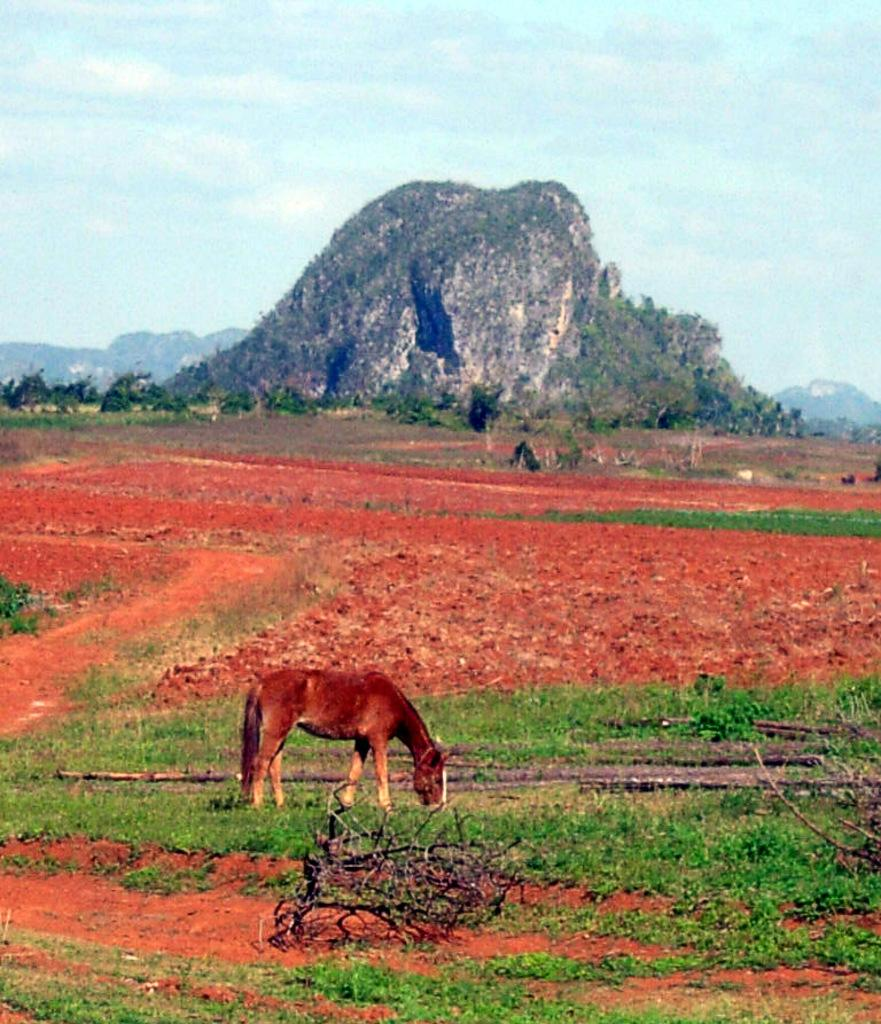What type of animal can be seen on the grass in the image? There is an animal on the surface of the grass in the image. What is the condition of the trees in the image? There are dry trees in the image. What can be seen in the distance behind the animal and trees? Mountains are visible in the background of the image. What is visible above the mountains and trees? The sky is visible in the background of the image. What type of nerve can be seen in the image? There is no nerve present in the image; it features an animal on the grass, dry trees, mountains, and the sky. 